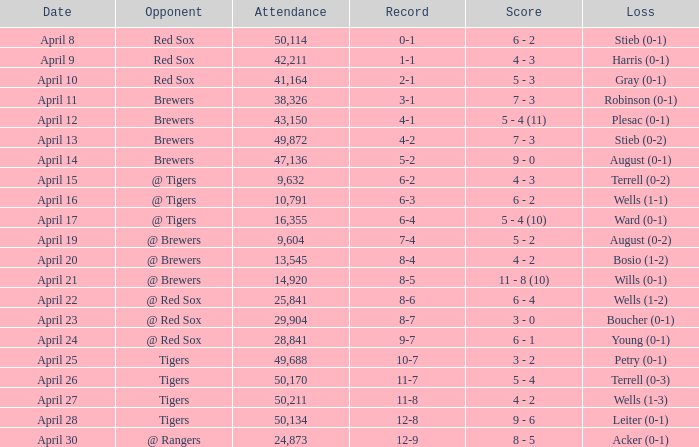Which opponent has an attendance greater than 29,904 and 11-8 as the record? Tigers. Would you be able to parse every entry in this table? {'header': ['Date', 'Opponent', 'Attendance', 'Record', 'Score', 'Loss'], 'rows': [['April 8', 'Red Sox', '50,114', '0-1', '6 - 2', 'Stieb (0-1)'], ['April 9', 'Red Sox', '42,211', '1-1', '4 - 3', 'Harris (0-1)'], ['April 10', 'Red Sox', '41,164', '2-1', '5 - 3', 'Gray (0-1)'], ['April 11', 'Brewers', '38,326', '3-1', '7 - 3', 'Robinson (0-1)'], ['April 12', 'Brewers', '43,150', '4-1', '5 - 4 (11)', 'Plesac (0-1)'], ['April 13', 'Brewers', '49,872', '4-2', '7 - 3', 'Stieb (0-2)'], ['April 14', 'Brewers', '47,136', '5-2', '9 - 0', 'August (0-1)'], ['April 15', '@ Tigers', '9,632', '6-2', '4 - 3', 'Terrell (0-2)'], ['April 16', '@ Tigers', '10,791', '6-3', '6 - 2', 'Wells (1-1)'], ['April 17', '@ Tigers', '16,355', '6-4', '5 - 4 (10)', 'Ward (0-1)'], ['April 19', '@ Brewers', '9,604', '7-4', '5 - 2', 'August (0-2)'], ['April 20', '@ Brewers', '13,545', '8-4', '4 - 2', 'Bosio (1-2)'], ['April 21', '@ Brewers', '14,920', '8-5', '11 - 8 (10)', 'Wills (0-1)'], ['April 22', '@ Red Sox', '25,841', '8-6', '6 - 4', 'Wells (1-2)'], ['April 23', '@ Red Sox', '29,904', '8-7', '3 - 0', 'Boucher (0-1)'], ['April 24', '@ Red Sox', '28,841', '9-7', '6 - 1', 'Young (0-1)'], ['April 25', 'Tigers', '49,688', '10-7', '3 - 2', 'Petry (0-1)'], ['April 26', 'Tigers', '50,170', '11-7', '5 - 4', 'Terrell (0-3)'], ['April 27', 'Tigers', '50,211', '11-8', '4 - 2', 'Wells (1-3)'], ['April 28', 'Tigers', '50,134', '12-8', '9 - 6', 'Leiter (0-1)'], ['April 30', '@ Rangers', '24,873', '12-9', '8 - 5', 'Acker (0-1)']]} 